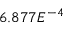<formula> <loc_0><loc_0><loc_500><loc_500>6 . 8 7 7 E ^ { - 4 }</formula> 